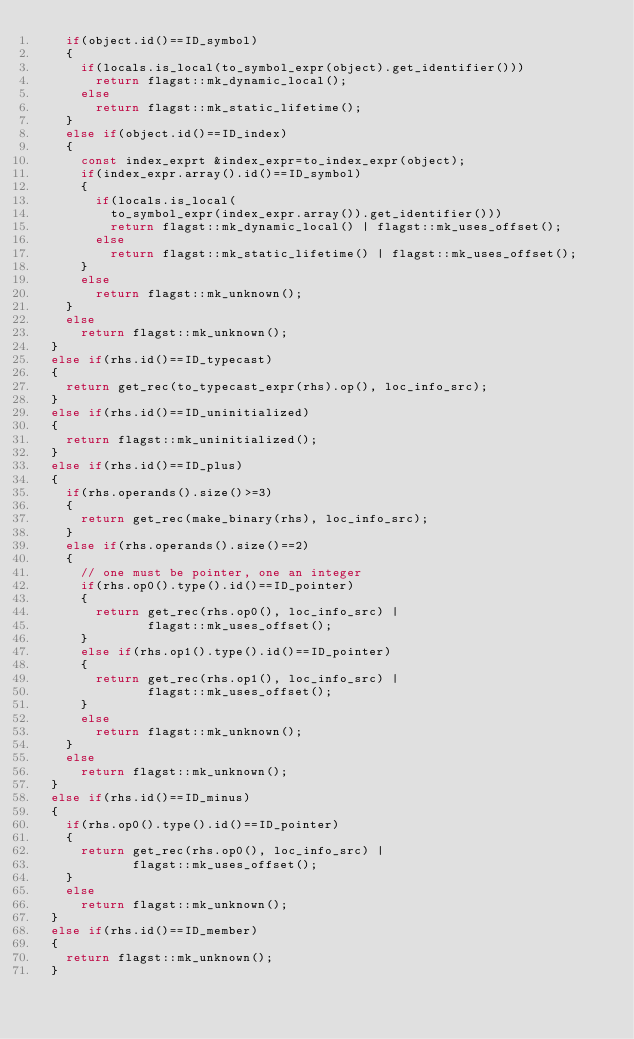Convert code to text. <code><loc_0><loc_0><loc_500><loc_500><_C++_>    if(object.id()==ID_symbol)
    {
      if(locals.is_local(to_symbol_expr(object).get_identifier()))
        return flagst::mk_dynamic_local();
      else
        return flagst::mk_static_lifetime();
    }
    else if(object.id()==ID_index)
    {
      const index_exprt &index_expr=to_index_expr(object);
      if(index_expr.array().id()==ID_symbol)
      {
        if(locals.is_local(
          to_symbol_expr(index_expr.array()).get_identifier()))
          return flagst::mk_dynamic_local() | flagst::mk_uses_offset();
        else
          return flagst::mk_static_lifetime() | flagst::mk_uses_offset();
      }
      else
        return flagst::mk_unknown();
    }
    else
      return flagst::mk_unknown();
  }
  else if(rhs.id()==ID_typecast)
  {
    return get_rec(to_typecast_expr(rhs).op(), loc_info_src);
  }
  else if(rhs.id()==ID_uninitialized)
  {
    return flagst::mk_uninitialized();
  }
  else if(rhs.id()==ID_plus)
  {
    if(rhs.operands().size()>=3)
    {
      return get_rec(make_binary(rhs), loc_info_src);
    }
    else if(rhs.operands().size()==2)
    {
      // one must be pointer, one an integer
      if(rhs.op0().type().id()==ID_pointer)
      {
        return get_rec(rhs.op0(), loc_info_src) |
               flagst::mk_uses_offset();
      }
      else if(rhs.op1().type().id()==ID_pointer)
      {
        return get_rec(rhs.op1(), loc_info_src) |
               flagst::mk_uses_offset();
      }
      else
        return flagst::mk_unknown();
    }
    else
      return flagst::mk_unknown();
  }
  else if(rhs.id()==ID_minus)
  {
    if(rhs.op0().type().id()==ID_pointer)
    {
      return get_rec(rhs.op0(), loc_info_src) |
             flagst::mk_uses_offset();
    }
    else
      return flagst::mk_unknown();
  }
  else if(rhs.id()==ID_member)
  {
    return flagst::mk_unknown();
  }</code> 